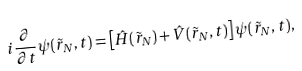Convert formula to latex. <formula><loc_0><loc_0><loc_500><loc_500>i \frac { \partial } { \partial t } \psi ( \tilde { r } _ { N } , t ) = \left [ \hat { H } ( \tilde { r } _ { N } ) + \hat { V } ( \tilde { r } _ { N } , t ) \right ] \psi ( \tilde { r } _ { N } , t ) ,</formula> 